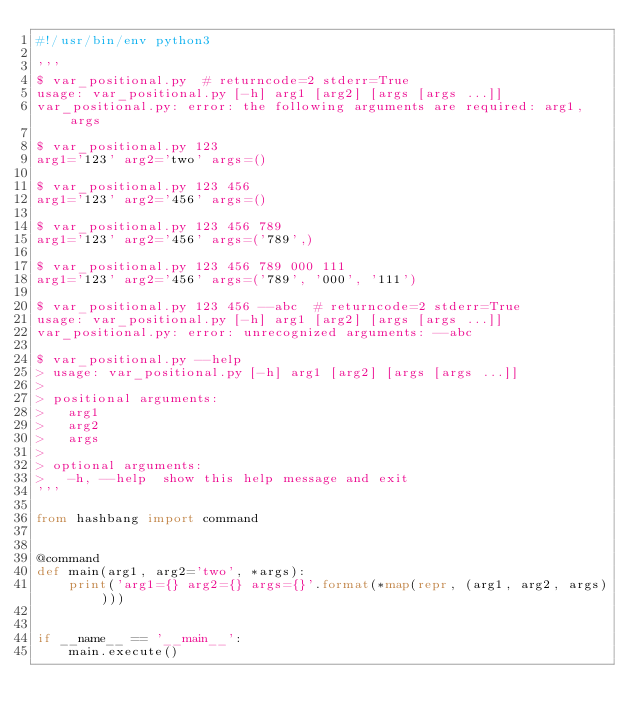Convert code to text. <code><loc_0><loc_0><loc_500><loc_500><_Python_>#!/usr/bin/env python3

'''
$ var_positional.py  # returncode=2 stderr=True
usage: var_positional.py [-h] arg1 [arg2] [args [args ...]]
var_positional.py: error: the following arguments are required: arg1, args

$ var_positional.py 123
arg1='123' arg2='two' args=()

$ var_positional.py 123 456
arg1='123' arg2='456' args=()

$ var_positional.py 123 456 789
arg1='123' arg2='456' args=('789',)

$ var_positional.py 123 456 789 000 111
arg1='123' arg2='456' args=('789', '000', '111')

$ var_positional.py 123 456 --abc  # returncode=2 stderr=True
usage: var_positional.py [-h] arg1 [arg2] [args [args ...]]
var_positional.py: error: unrecognized arguments: --abc

$ var_positional.py --help
> usage: var_positional.py [-h] arg1 [arg2] [args [args ...]]
>
> positional arguments:
>   arg1
>   arg2
>   args
>
> optional arguments:
>   -h, --help  show this help message and exit
'''

from hashbang import command


@command
def main(arg1, arg2='two', *args):
    print('arg1={} arg2={} args={}'.format(*map(repr, (arg1, arg2, args))))


if __name__ == '__main__':
    main.execute()
</code> 